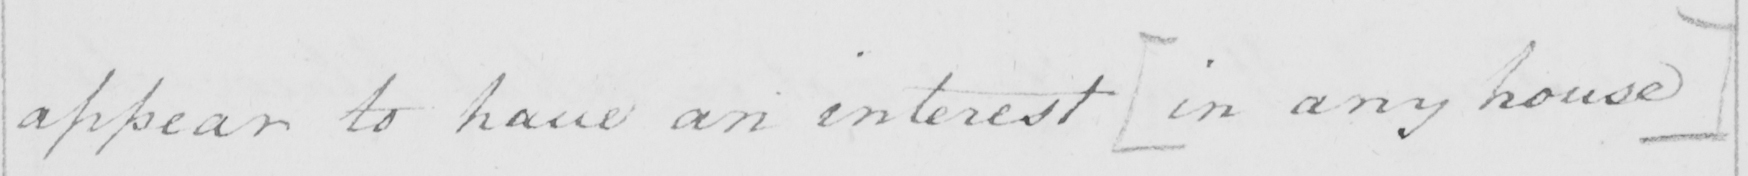What is written in this line of handwriting? appear to have an interest  [ in any house ] 